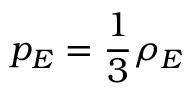Convert formula to latex. <formula><loc_0><loc_0><loc_500><loc_500>p _ { E } = \frac { 1 } { 3 } \rho _ { E }</formula> 